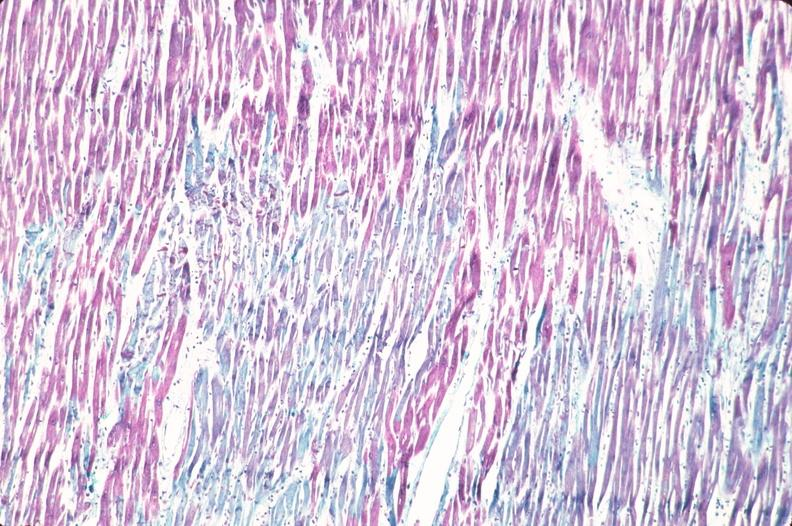what stain?
Answer the question using a single word or phrase. Aldehyde fuscin 